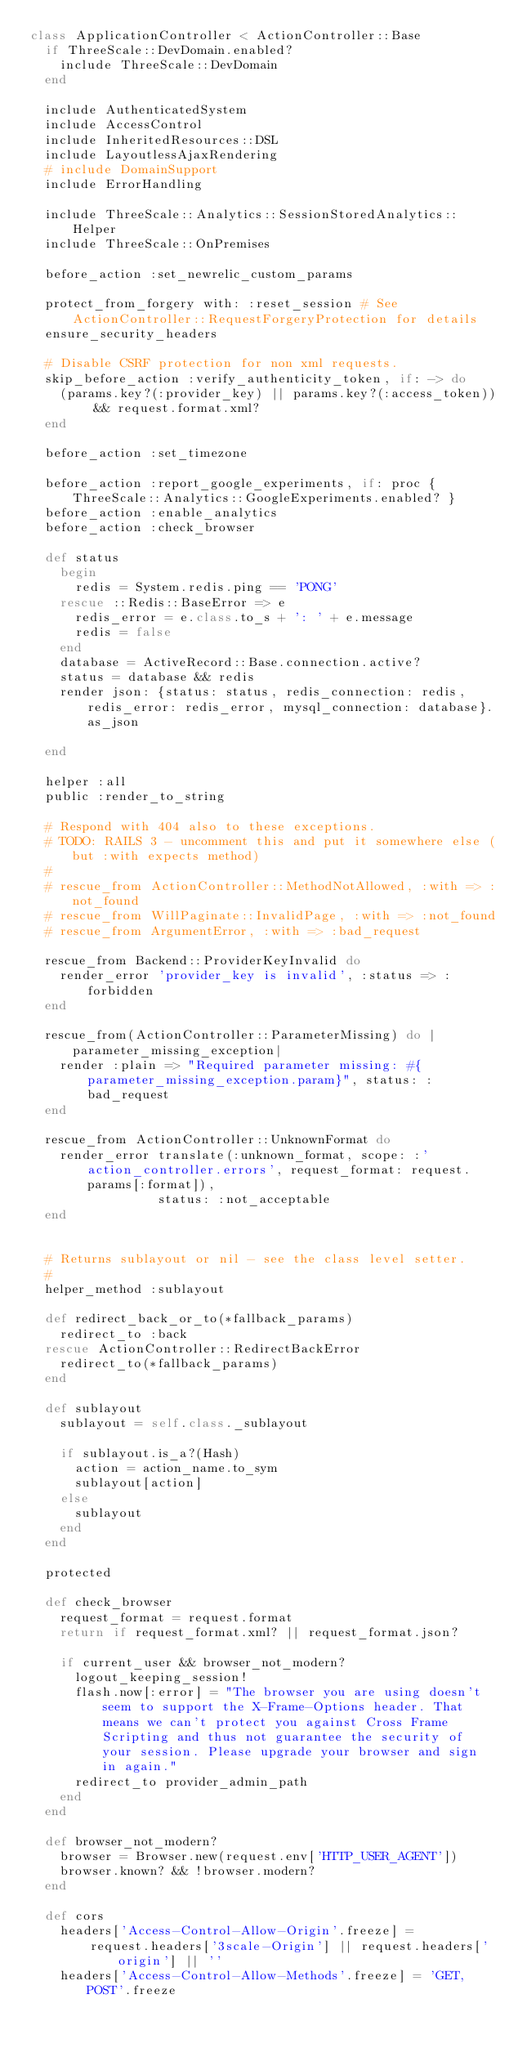<code> <loc_0><loc_0><loc_500><loc_500><_Ruby_>class ApplicationController < ActionController::Base
  if ThreeScale::DevDomain.enabled?
    include ThreeScale::DevDomain
  end

  include AuthenticatedSystem
  include AccessControl
  include InheritedResources::DSL
  include LayoutlessAjaxRendering
  # include DomainSupport
  include ErrorHandling

  include ThreeScale::Analytics::SessionStoredAnalytics::Helper
  include ThreeScale::OnPremises

  before_action :set_newrelic_custom_params

  protect_from_forgery with: :reset_session # See ActionController::RequestForgeryProtection for details
  ensure_security_headers

  # Disable CSRF protection for non xml requests.
  skip_before_action :verify_authenticity_token, if: -> do
    (params.key?(:provider_key) || params.key?(:access_token)) && request.format.xml?
  end

  before_action :set_timezone

  before_action :report_google_experiments, if: proc { ThreeScale::Analytics::GoogleExperiments.enabled? }
  before_action :enable_analytics
  before_action :check_browser

  def status
    begin
      redis = System.redis.ping == 'PONG'
    rescue ::Redis::BaseError => e
      redis_error = e.class.to_s + ': ' + e.message
      redis = false
    end
    database = ActiveRecord::Base.connection.active?
    status = database && redis
    render json: {status: status, redis_connection: redis, redis_error: redis_error, mysql_connection: database}.as_json

  end

  helper :all
  public :render_to_string

  # Respond with 404 also to these exceptions.
  # TODO: RAILS 3 - uncomment this and put it somewhere else (but :with expects method)
  #
  # rescue_from ActionController::MethodNotAllowed, :with => :not_found
  # rescue_from WillPaginate::InvalidPage, :with => :not_found
  # rescue_from ArgumentError, :with => :bad_request

  rescue_from Backend::ProviderKeyInvalid do
    render_error 'provider_key is invalid', :status => :forbidden
  end

  rescue_from(ActionController::ParameterMissing) do |parameter_missing_exception|
    render :plain => "Required parameter missing: #{parameter_missing_exception.param}", status: :bad_request
  end

  rescue_from ActionController::UnknownFormat do
    render_error translate(:unknown_format, scope: :'action_controller.errors', request_format: request.params[:format]),
                 status: :not_acceptable
  end


  # Returns sublayout or nil - see the class level setter.
  #
  helper_method :sublayout

  def redirect_back_or_to(*fallback_params)
    redirect_to :back
  rescue ActionController::RedirectBackError
    redirect_to(*fallback_params)
  end

  def sublayout
    sublayout = self.class._sublayout

    if sublayout.is_a?(Hash)
      action = action_name.to_sym
      sublayout[action]
    else
      sublayout
    end
  end

  protected

  def check_browser
    request_format = request.format
    return if request_format.xml? || request_format.json?

    if current_user && browser_not_modern?
      logout_keeping_session!
      flash.now[:error] = "The browser you are using doesn't seem to support the X-Frame-Options header. That means we can't protect you against Cross Frame Scripting and thus not guarantee the security of your session. Please upgrade your browser and sign in again."
      redirect_to provider_admin_path
    end
  end

  def browser_not_modern?
    browser = Browser.new(request.env['HTTP_USER_AGENT'])
    browser.known? && !browser.modern?
  end

  def cors
    headers['Access-Control-Allow-Origin'.freeze] =
        request.headers['3scale-Origin'] || request.headers['origin'] || ''
    headers['Access-Control-Allow-Methods'.freeze] = 'GET, POST'.freeze</code> 